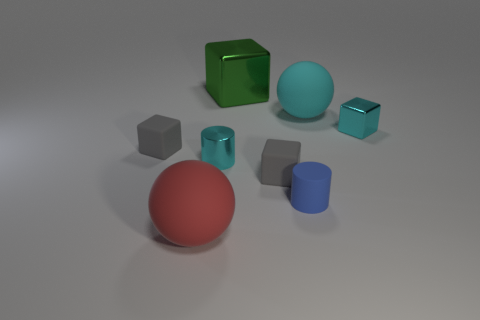There is a cyan matte ball on the right side of the red rubber object; how many small cubes are on the left side of it?
Make the answer very short. 2. Are the cyan thing left of the large cyan rubber object and the large ball that is to the right of the large block made of the same material?
Your response must be concise. No. What material is the big object that is the same color as the small shiny cylinder?
Your answer should be very brief. Rubber. How many tiny gray things are the same shape as the large green thing?
Provide a short and direct response. 2. Does the blue cylinder have the same material as the gray block on the right side of the shiny cylinder?
Your answer should be very brief. Yes. There is a red thing that is the same size as the cyan matte sphere; what material is it?
Your response must be concise. Rubber. Is there another cyan ball that has the same size as the cyan matte ball?
Make the answer very short. No. There is a cyan matte thing that is the same size as the green cube; what shape is it?
Offer a very short reply. Sphere. How many other objects are there of the same color as the small metallic block?
Keep it short and to the point. 2. There is a object that is both to the right of the tiny blue matte thing and behind the cyan cube; what shape is it?
Provide a short and direct response. Sphere. 